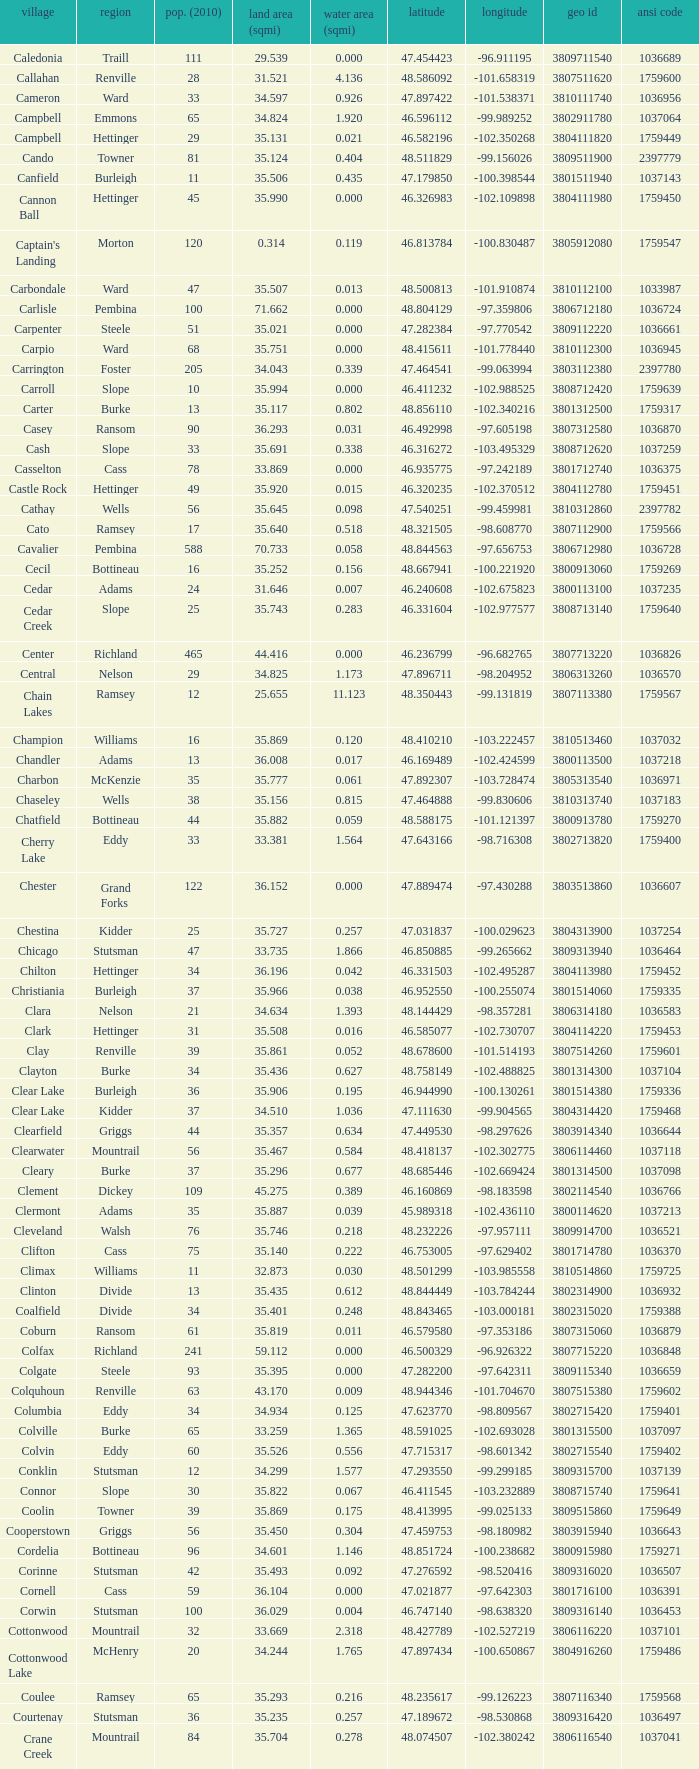What was the county with a longitude of -102.302775? Mountrail. 